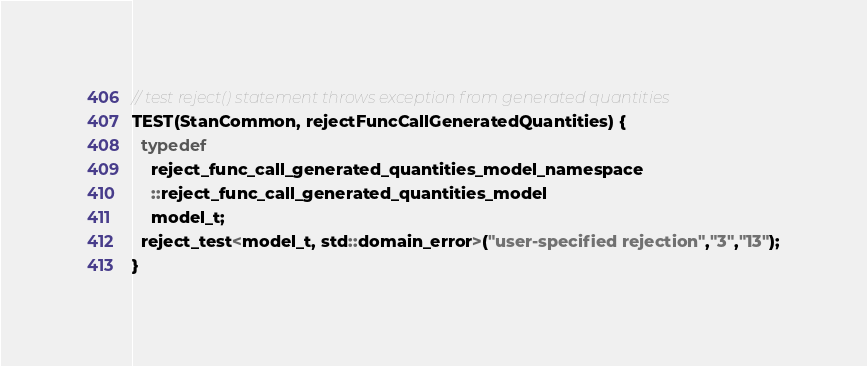<code> <loc_0><loc_0><loc_500><loc_500><_C++_>// test reject() statement throws exception from generated quantities
TEST(StanCommon, rejectFuncCallGeneratedQuantities) {
  typedef 
    reject_func_call_generated_quantities_model_namespace
    ::reject_func_call_generated_quantities_model 
    model_t;
  reject_test<model_t, std::domain_error>("user-specified rejection","3","13");
}
</code> 